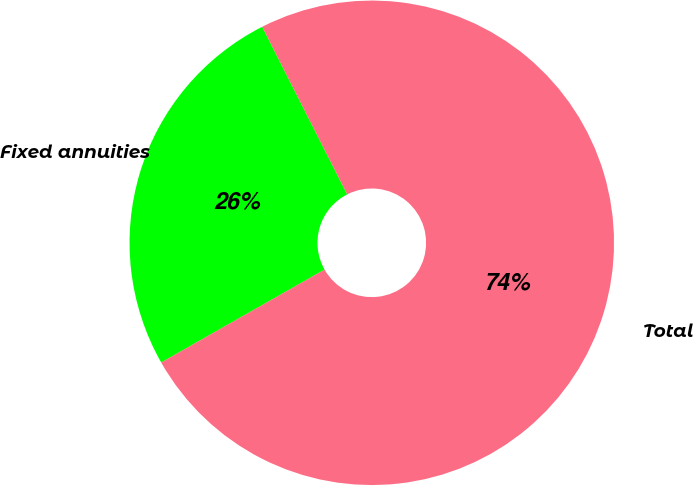<chart> <loc_0><loc_0><loc_500><loc_500><pie_chart><fcel>Fixed annuities<fcel>Total<nl><fcel>25.76%<fcel>74.24%<nl></chart> 